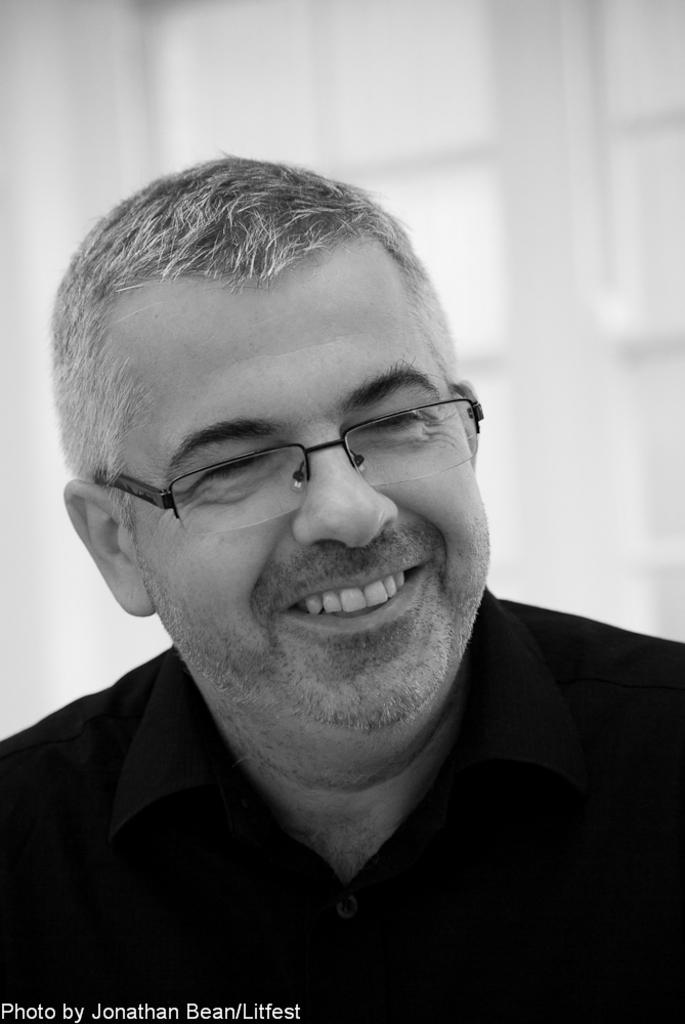What is the main subject of the image? There is a person in the image. What is the person's facial expression? The person is smiling. Can you describe the background of the image? There appears to be a door behind the person. What type of jeans is the person wearing in the image? There is no information about the person's clothing in the image, so it cannot be determined if they are wearing jeans or any other type of clothing. What religious beliefs does the person in the image follow? There is no information about the person's religious beliefs in the image. Is there a bun visible in the image? There is no mention of a bun or any other food item in the image. 